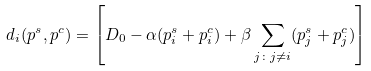<formula> <loc_0><loc_0><loc_500><loc_500>d _ { i } ( p ^ { s } , p ^ { c } ) = \left [ D _ { 0 } - \alpha ( p ^ { s } _ { i } + p ^ { c } _ { i } ) + \beta \sum _ { j \colon j \neq i } ( p ^ { s } _ { j } + p ^ { c } _ { j } ) \right ]</formula> 